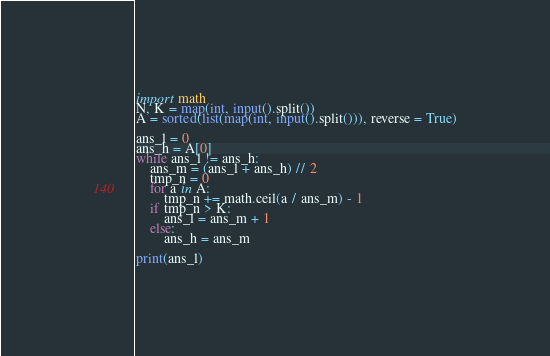<code> <loc_0><loc_0><loc_500><loc_500><_Python_>import math
N, K = map(int, input().split())
A = sorted(list(map(int, input().split())), reverse = True)

ans_l = 0
ans_h = A[0]
while ans_l != ans_h:
    ans_m = (ans_l + ans_h) // 2
    tmp_n = 0
    for a in A:
        tmp_n += math.ceil(a / ans_m) - 1
    if tmp_n > K:
        ans_l = ans_m + 1
    else:
        ans_h = ans_m

print(ans_l)</code> 